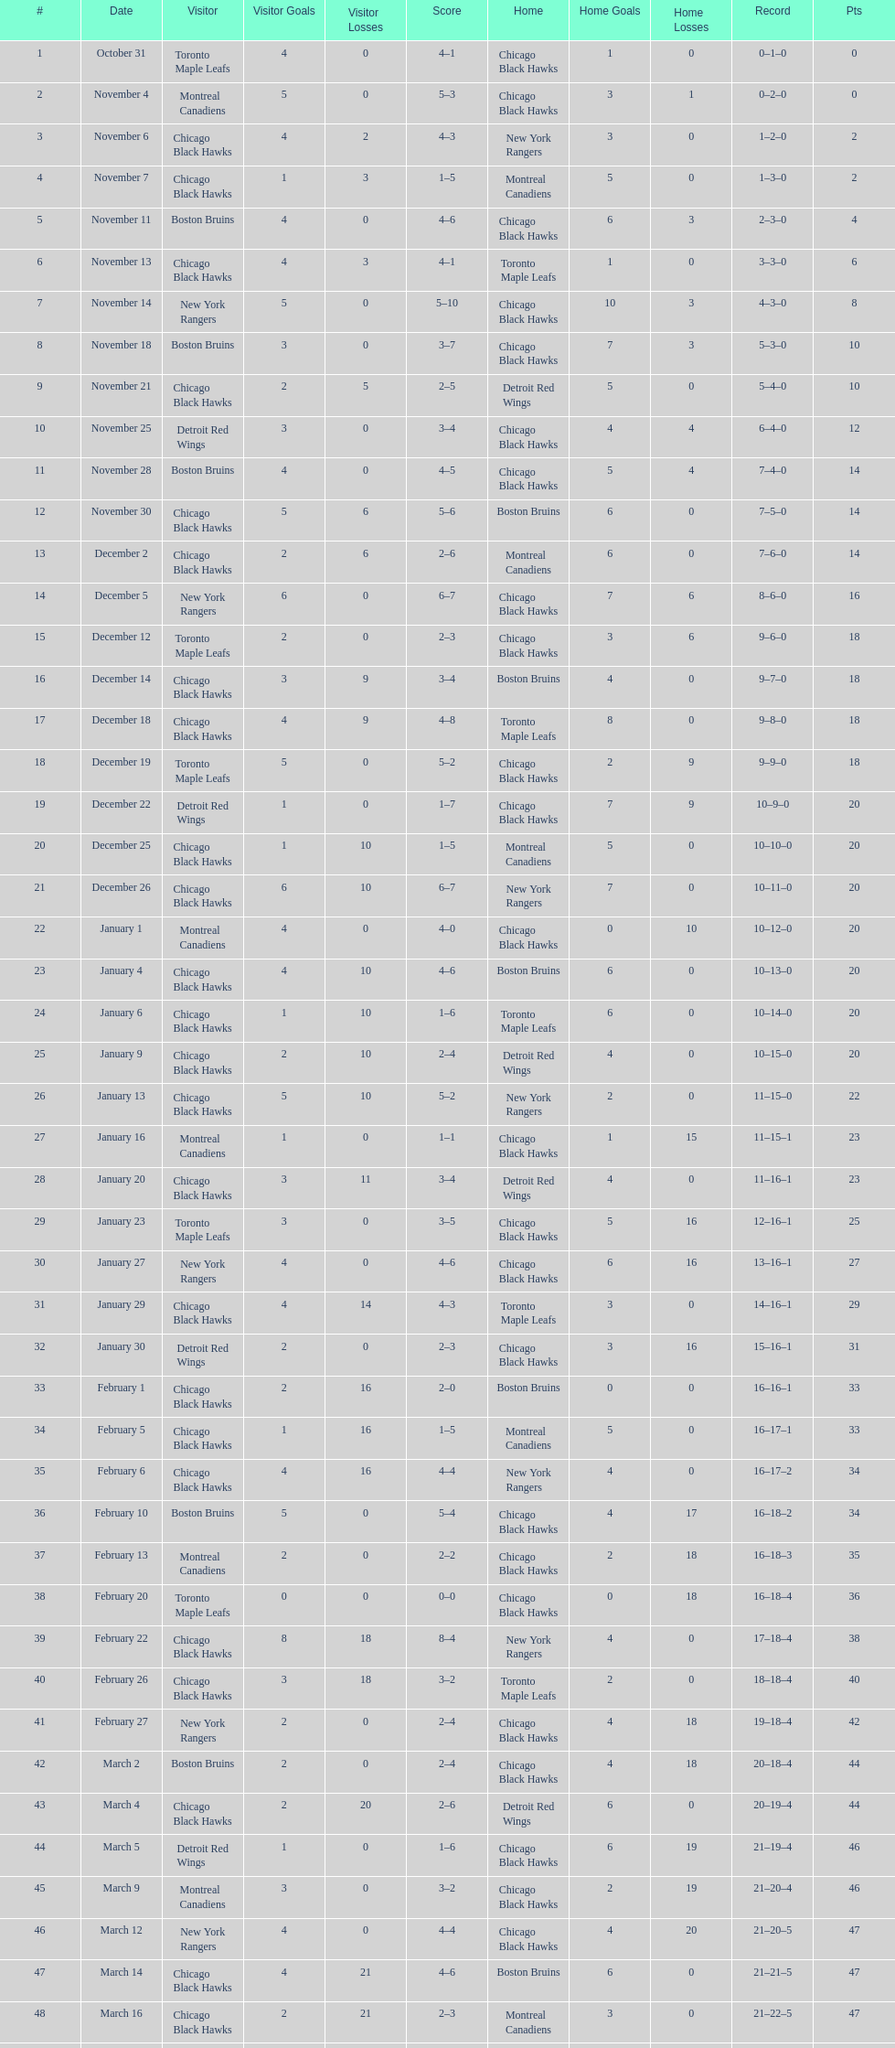Provide the total of points the blackhawks held on march 44. 